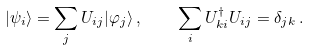<formula> <loc_0><loc_0><loc_500><loc_500>| \psi _ { i } \rangle = \sum _ { j } U _ { i j } | \varphi _ { j } \rangle \, , \quad \sum _ { i } U ^ { \dagger } _ { k i } U _ { i j } = \delta _ { j k } \, .</formula> 